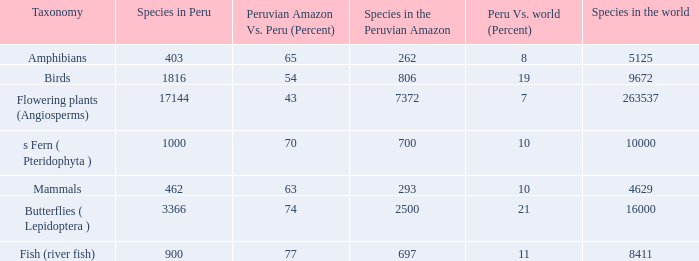What's the minimum species in the peruvian amazon with species in peru of 1000 700.0. 